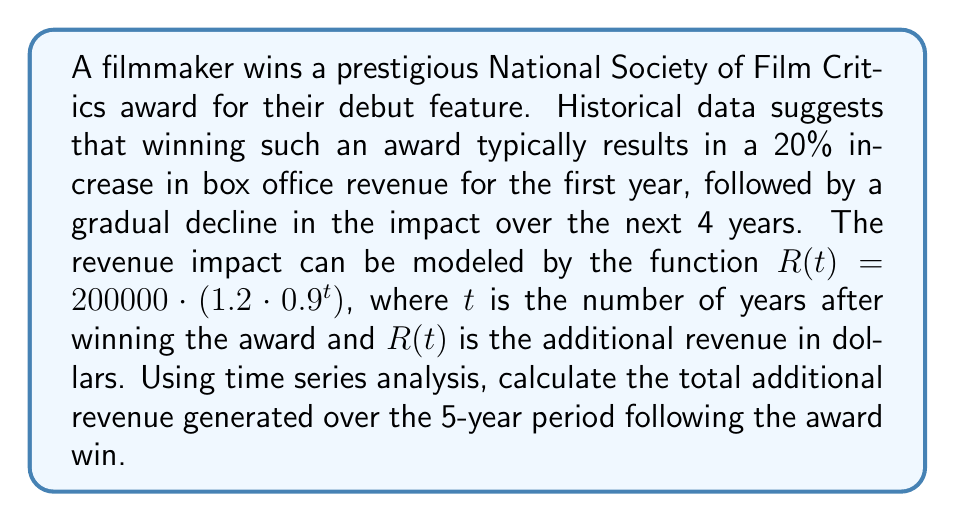What is the answer to this math problem? To solve this problem, we need to use time series analysis to calculate the sum of the additional revenue over the 5-year period. Let's break it down step by step:

1) The given function for additional revenue is:
   $R(t) = 200000 \cdot (1.2 \cdot 0.9^t)$

2) We need to calculate this for $t = 0, 1, 2, 3, 4$ (representing the 5 years) and sum the results.

3) Let's calculate each year's additional revenue:

   Year 0 (immediately after winning): $R(0) = 200000 \cdot (1.2 \cdot 0.9^0) = 240000$
   Year 1: $R(1) = 200000 \cdot (1.2 \cdot 0.9^1) = 216000$
   Year 2: $R(2) = 200000 \cdot (1.2 \cdot 0.9^2) = 194400$
   Year 3: $R(3) = 200000 \cdot (1.2 \cdot 0.9^3) = 174960$
   Year 4: $R(4) = 200000 \cdot (1.2 \cdot 0.9^4) = 157464$

4) Now, we need to sum these values:

   $\text{Total Additional Revenue} = \sum_{t=0}^4 R(t)$

   $= 240000 + 216000 + 194400 + 174960 + 157464$

   $= 982824$

Therefore, the total additional revenue generated over the 5-year period is $982,824.

Alternatively, we could have used the formula for the sum of a geometric series:

$S_n = a \cdot \frac{1-r^n}{1-r}$, where $a$ is the first term, $r$ is the common ratio, and $n$ is the number of terms.

In our case, $a = 240000$, $r = 0.9$, and $n = 5$:

$S_5 = 240000 \cdot \frac{1-0.9^5}{1-0.9} = 982824$

This gives us the same result.
Answer: $982,824 